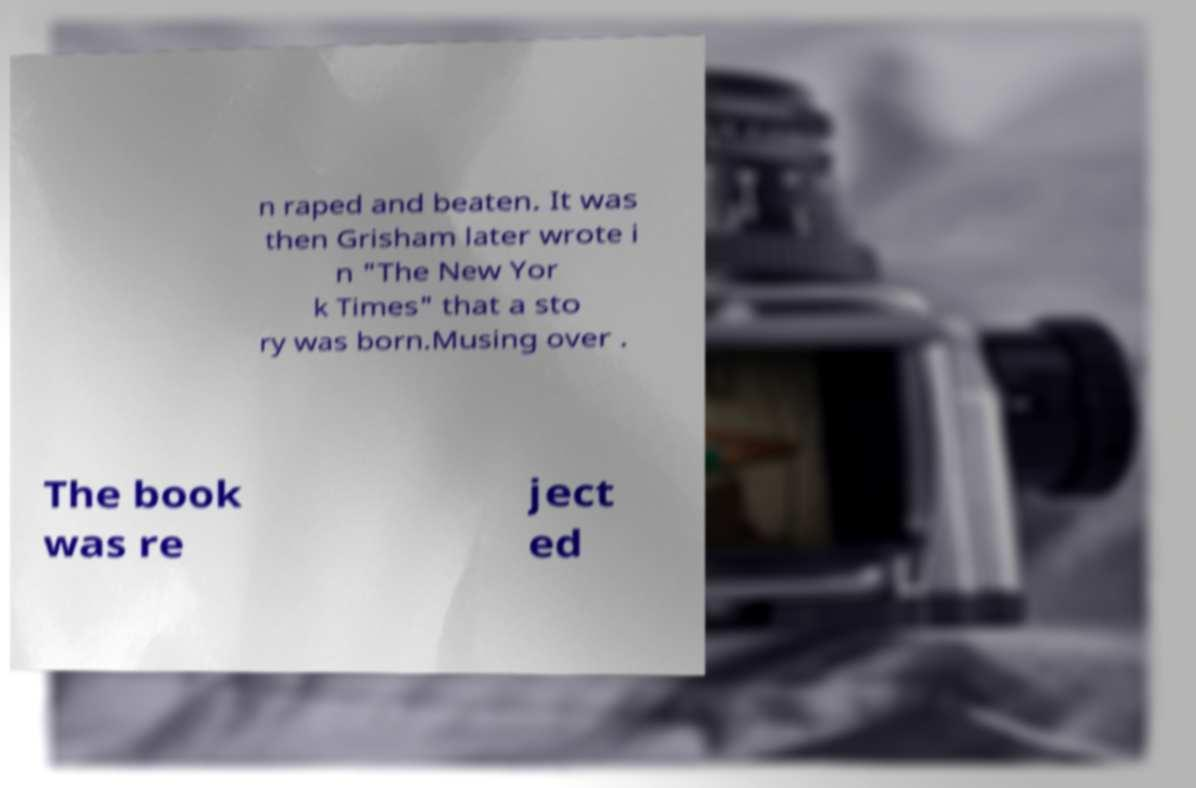What messages or text are displayed in this image? I need them in a readable, typed format. n raped and beaten. It was then Grisham later wrote i n "The New Yor k Times" that a sto ry was born.Musing over . The book was re ject ed 